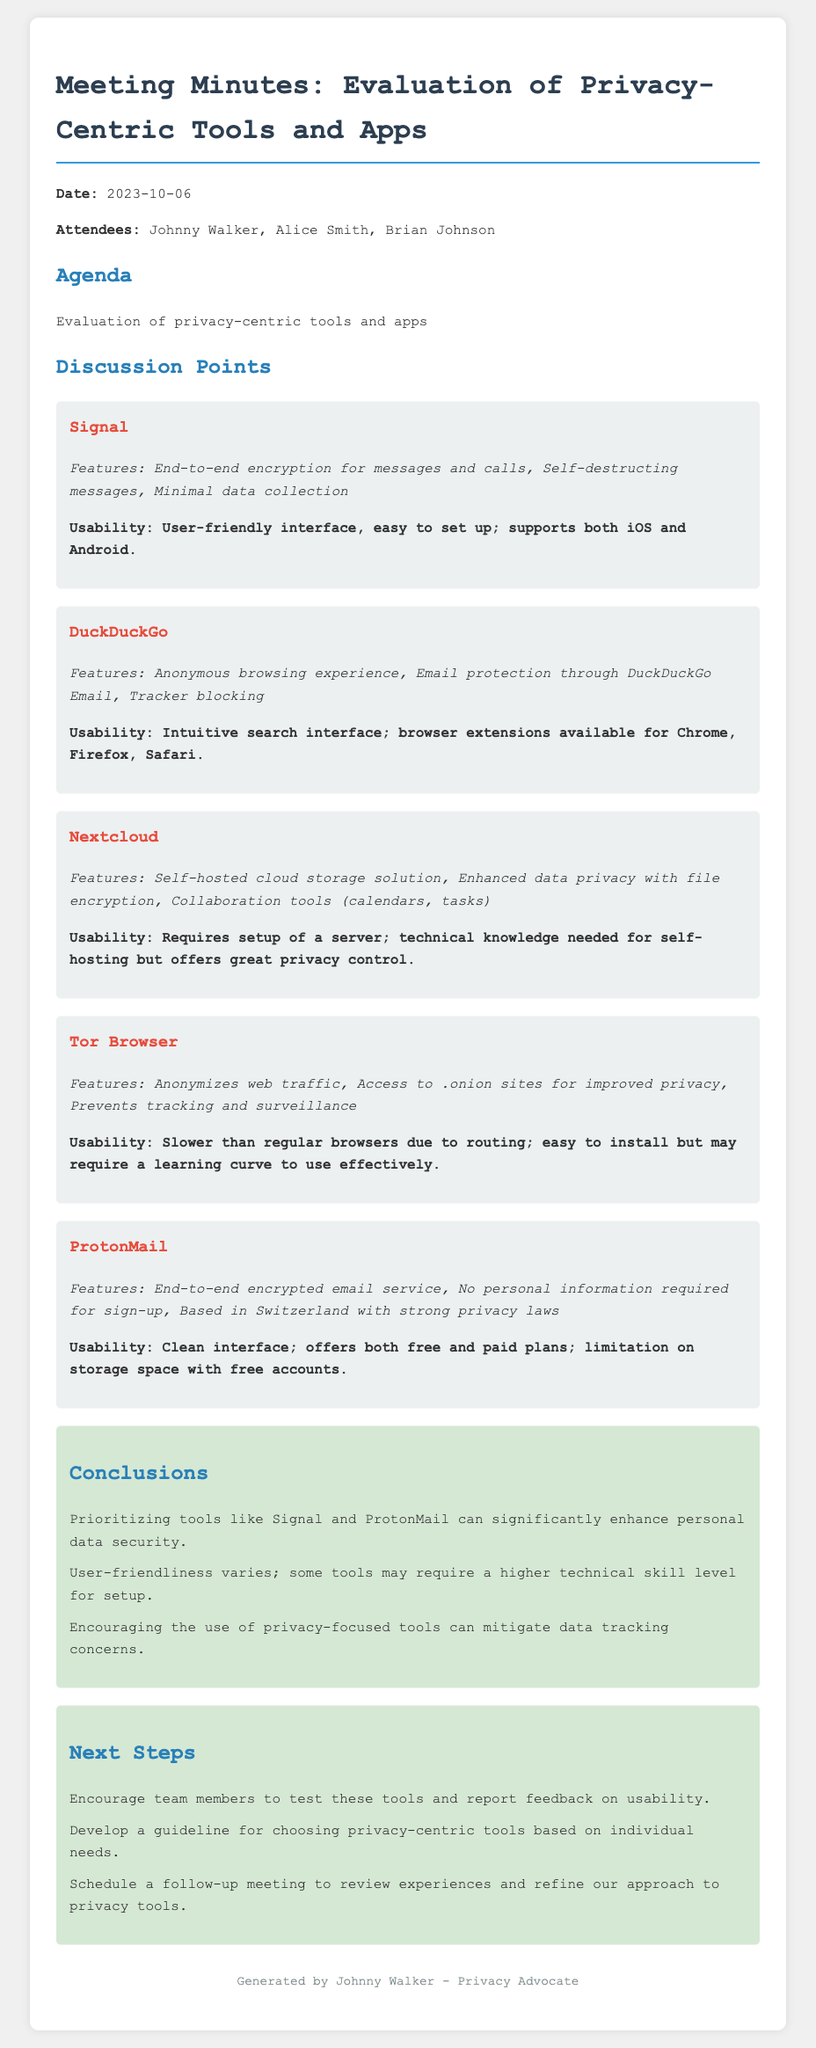what is the date of the meeting? The date of the meeting is stated at the beginning of the document.
Answer: 2023-10-06 who are the attendees of the meeting? The attendees are listed in the document, providing the names of all present members.
Answer: Johnny Walker, Alice Smith, Brian Johnson which tool features end-to-end encryption for messages and calls? This feature is specifically mentioned under one of the tools discussed in the meeting.
Answer: Signal what are the usability characteristics of DuckDuckGo? Usability details for DuckDuckGo are outlined under the tool’s section, describing its search interface.
Answer: Intuitive search interface; browser extensions available for Chrome, Firefox, Safari which two tools are prioritized for enhancing personal data security? This information is summarized in the conclusions section where specific tools are mentioned.
Answer: Signal and ProtonMail what is a requirement for using Nextcloud? The document highlights a particular aspect of usability related to setup before using this tool.
Answer: Requires setup of a server what is the email service location mentioned for ProtonMail? The document specifies the geographical location of ProtonMail, which is significant for privacy laws.
Answer: Switzerland how many next steps are outlined in the document? The document lists specific steps that follow the evaluation and discussion, indicating how many next steps were mentioned.
Answer: Three what is the purpose of the follow-up meeting? The next steps include scheduling a follow-up meeting, which has a stated goal in the document.
Answer: Review experiences and refine our approach to privacy tools 